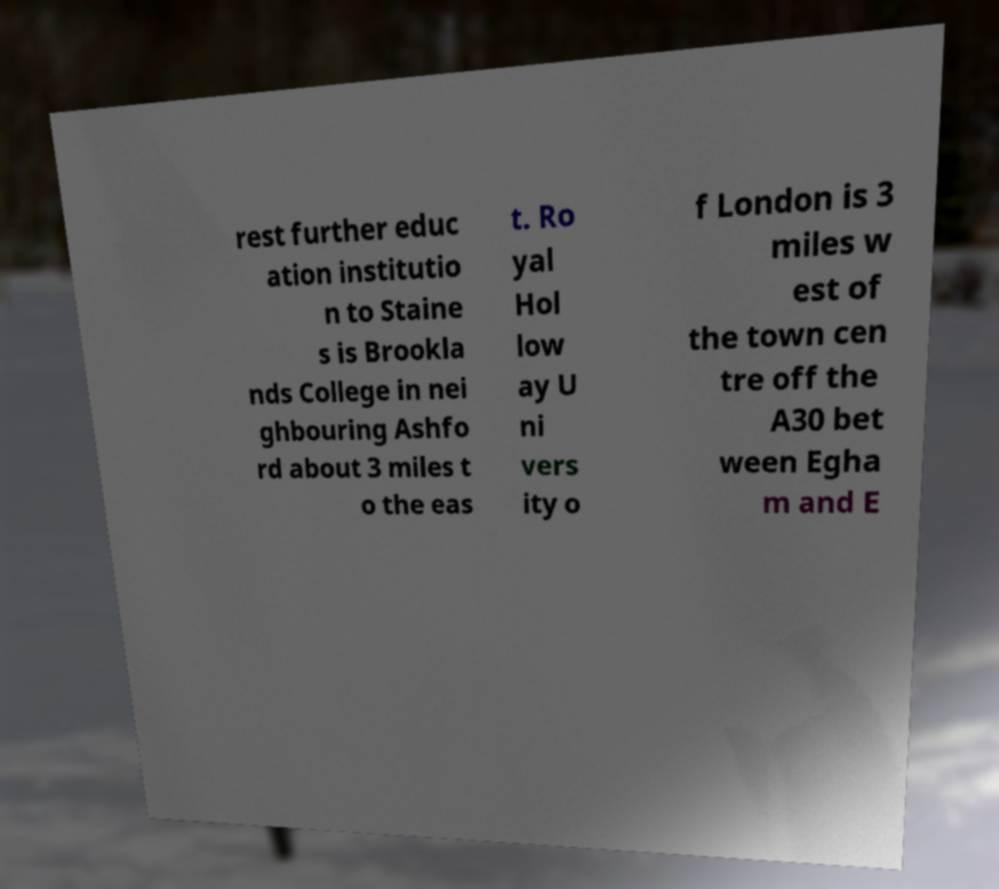There's text embedded in this image that I need extracted. Can you transcribe it verbatim? rest further educ ation institutio n to Staine s is Brookla nds College in nei ghbouring Ashfo rd about 3 miles t o the eas t. Ro yal Hol low ay U ni vers ity o f London is 3 miles w est of the town cen tre off the A30 bet ween Egha m and E 